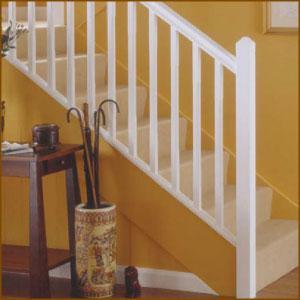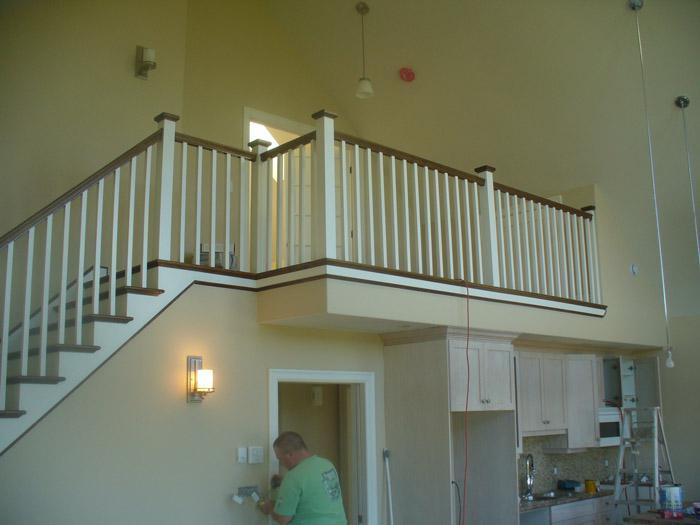The first image is the image on the left, the second image is the image on the right. Analyze the images presented: Is the assertion "In at least one image there is a stair cause with dark colored trim and white rods." valid? Answer yes or no. Yes. The first image is the image on the left, the second image is the image on the right. Assess this claim about the two images: "Framed pictures line the stairway in one of the images.". Correct or not? Answer yes or no. No. 